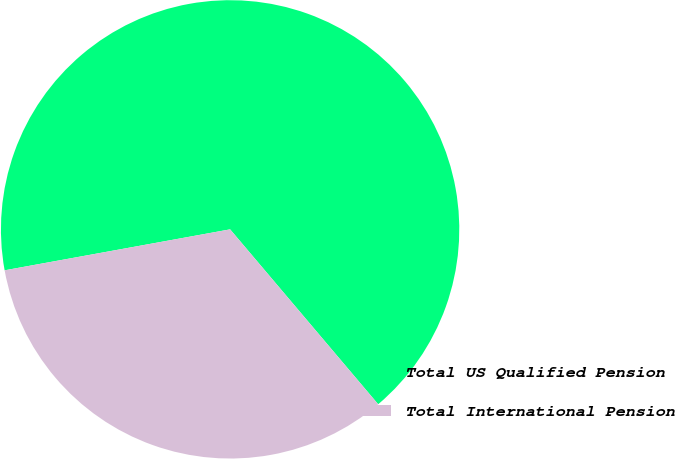Convert chart to OTSL. <chart><loc_0><loc_0><loc_500><loc_500><pie_chart><fcel>Total US Qualified Pension<fcel>Total International Pension<nl><fcel>66.68%<fcel>33.32%<nl></chart> 